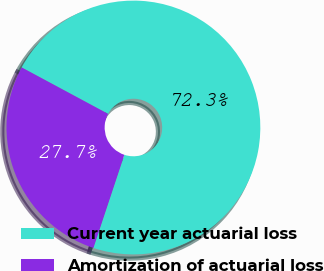Convert chart to OTSL. <chart><loc_0><loc_0><loc_500><loc_500><pie_chart><fcel>Current year actuarial loss<fcel>Amortization of actuarial loss<nl><fcel>72.26%<fcel>27.74%<nl></chart> 